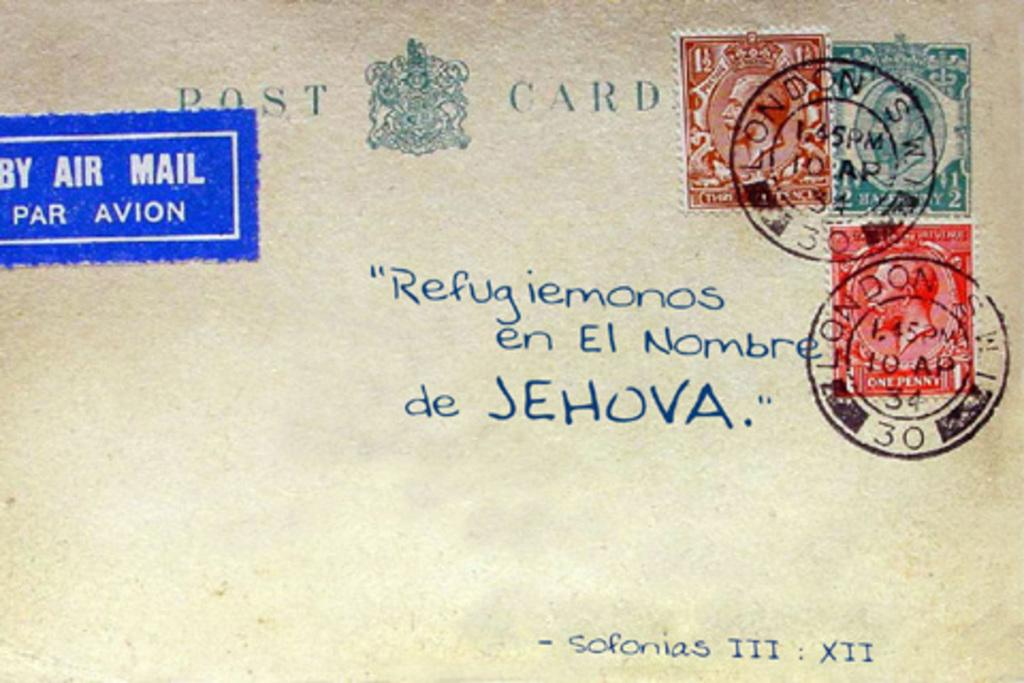<image>
Give a short and clear explanation of the subsequent image. A post card with stamps from London sent by Air Mail 